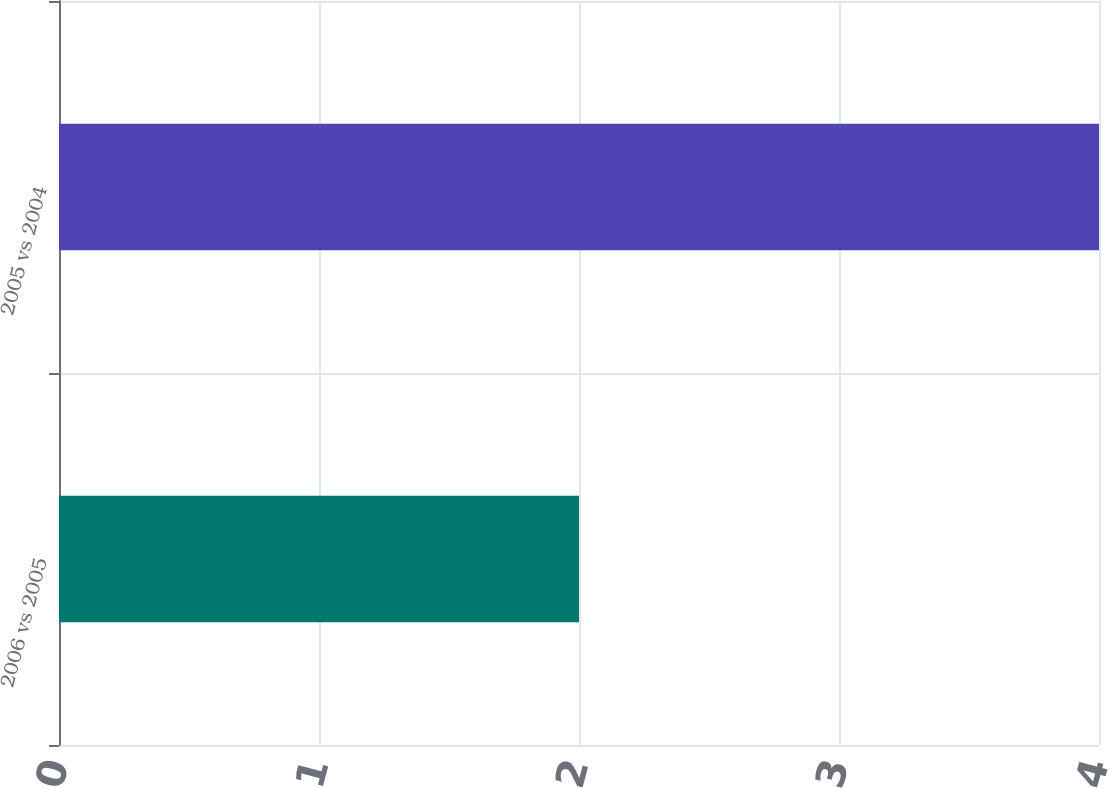Convert chart. <chart><loc_0><loc_0><loc_500><loc_500><bar_chart><fcel>2006 vs 2005<fcel>2005 vs 2004<nl><fcel>2<fcel>4<nl></chart> 